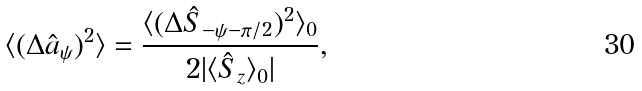<formula> <loc_0><loc_0><loc_500><loc_500>\langle ( \Delta \hat { a } _ { \psi } ) ^ { 2 } \rangle = \frac { \langle ( \Delta \hat { S } _ { - \psi - \pi / 2 } ) ^ { 2 } \rangle _ { 0 } } { 2 | \langle \hat { S } _ { z } \rangle _ { 0 } | } ,</formula> 